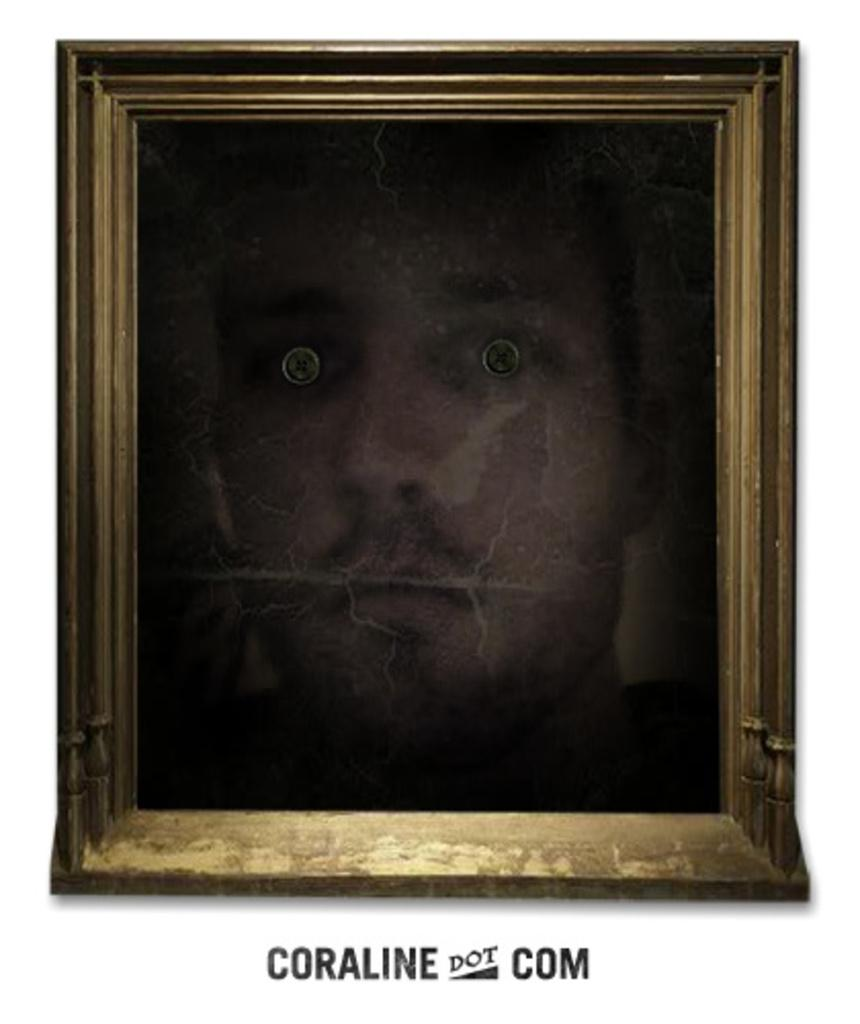<image>
Write a terse but informative summary of the picture. A scary face is framed with Coraline dot com written below it. 